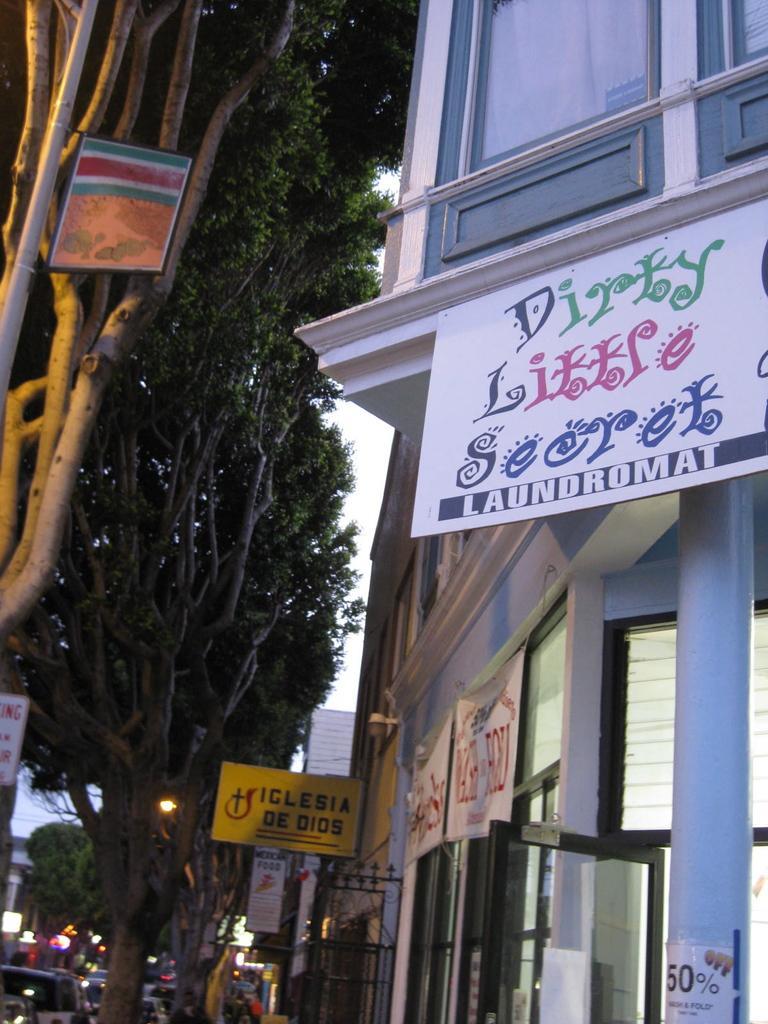Could you give a brief overview of what you see in this image? In the center of the image there are trees. On the right there is a building and we can see a board on it. At the bottom there are cars. 